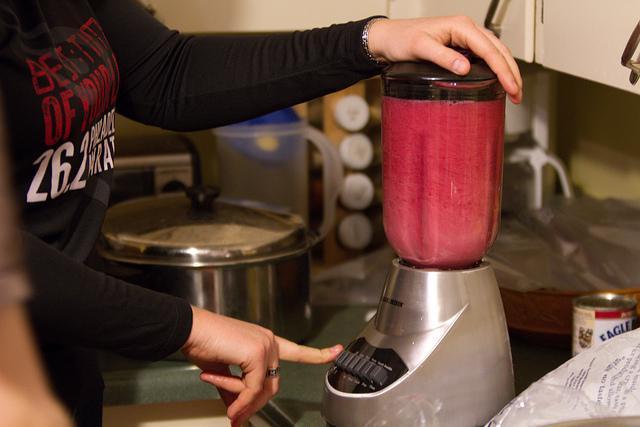How many clocks are in front of the man?
Give a very brief answer. 0. 